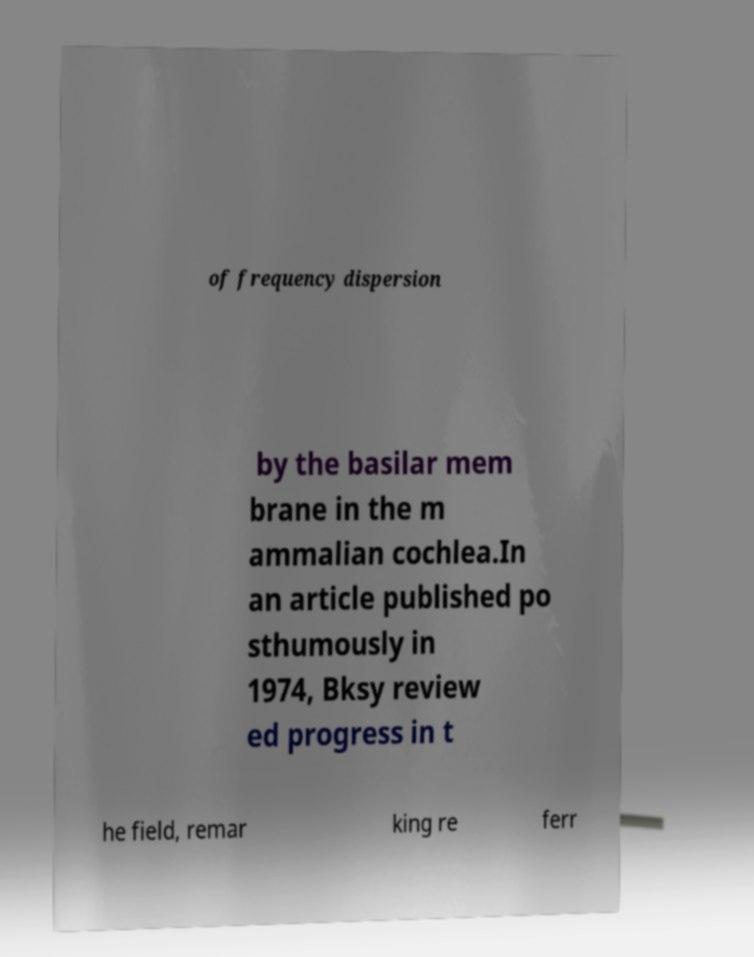Could you extract and type out the text from this image? of frequency dispersion by the basilar mem brane in the m ammalian cochlea.In an article published po sthumously in 1974, Bksy review ed progress in t he field, remar king re ferr 